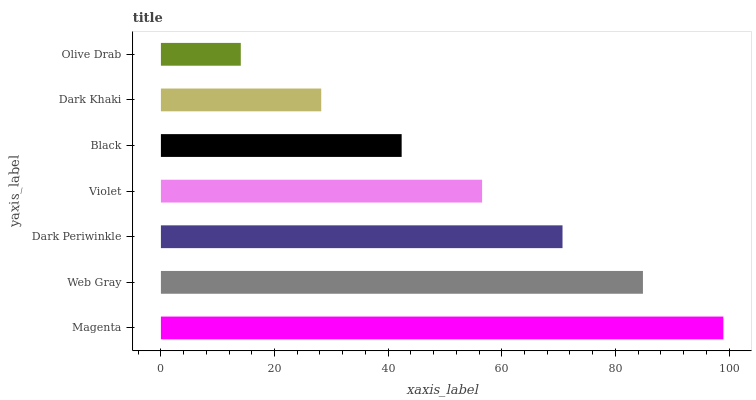Is Olive Drab the minimum?
Answer yes or no. Yes. Is Magenta the maximum?
Answer yes or no. Yes. Is Web Gray the minimum?
Answer yes or no. No. Is Web Gray the maximum?
Answer yes or no. No. Is Magenta greater than Web Gray?
Answer yes or no. Yes. Is Web Gray less than Magenta?
Answer yes or no. Yes. Is Web Gray greater than Magenta?
Answer yes or no. No. Is Magenta less than Web Gray?
Answer yes or no. No. Is Violet the high median?
Answer yes or no. Yes. Is Violet the low median?
Answer yes or no. Yes. Is Dark Khaki the high median?
Answer yes or no. No. Is Olive Drab the low median?
Answer yes or no. No. 